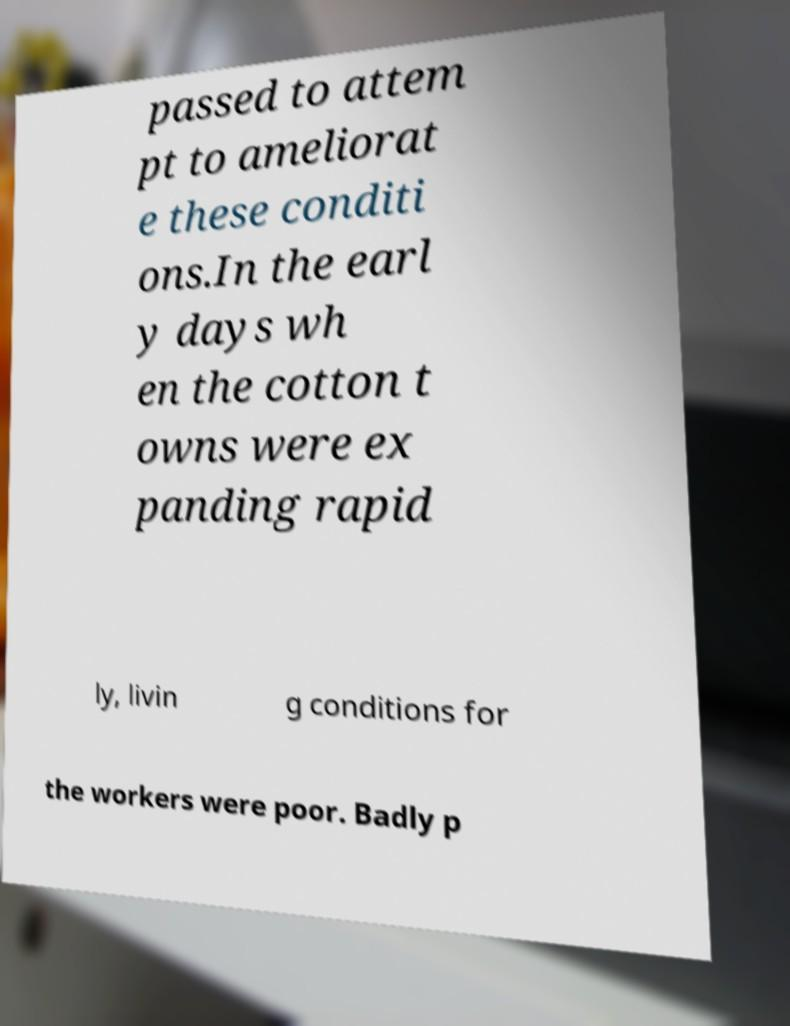Please read and relay the text visible in this image. What does it say? passed to attem pt to ameliorat e these conditi ons.In the earl y days wh en the cotton t owns were ex panding rapid ly, livin g conditions for the workers were poor. Badly p 